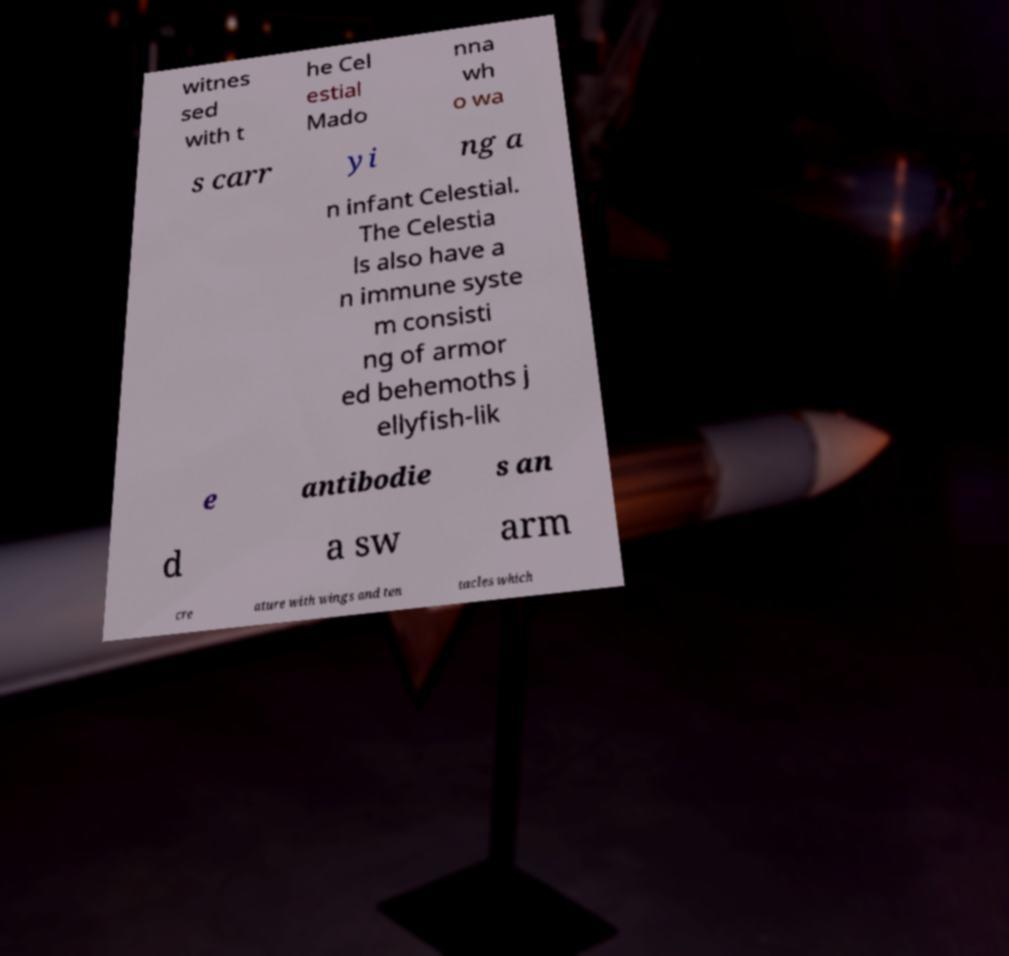What messages or text are displayed in this image? I need them in a readable, typed format. witnes sed with t he Cel estial Mado nna wh o wa s carr yi ng a n infant Celestial. The Celestia ls also have a n immune syste m consisti ng of armor ed behemoths j ellyfish-lik e antibodie s an d a sw arm cre ature with wings and ten tacles which 